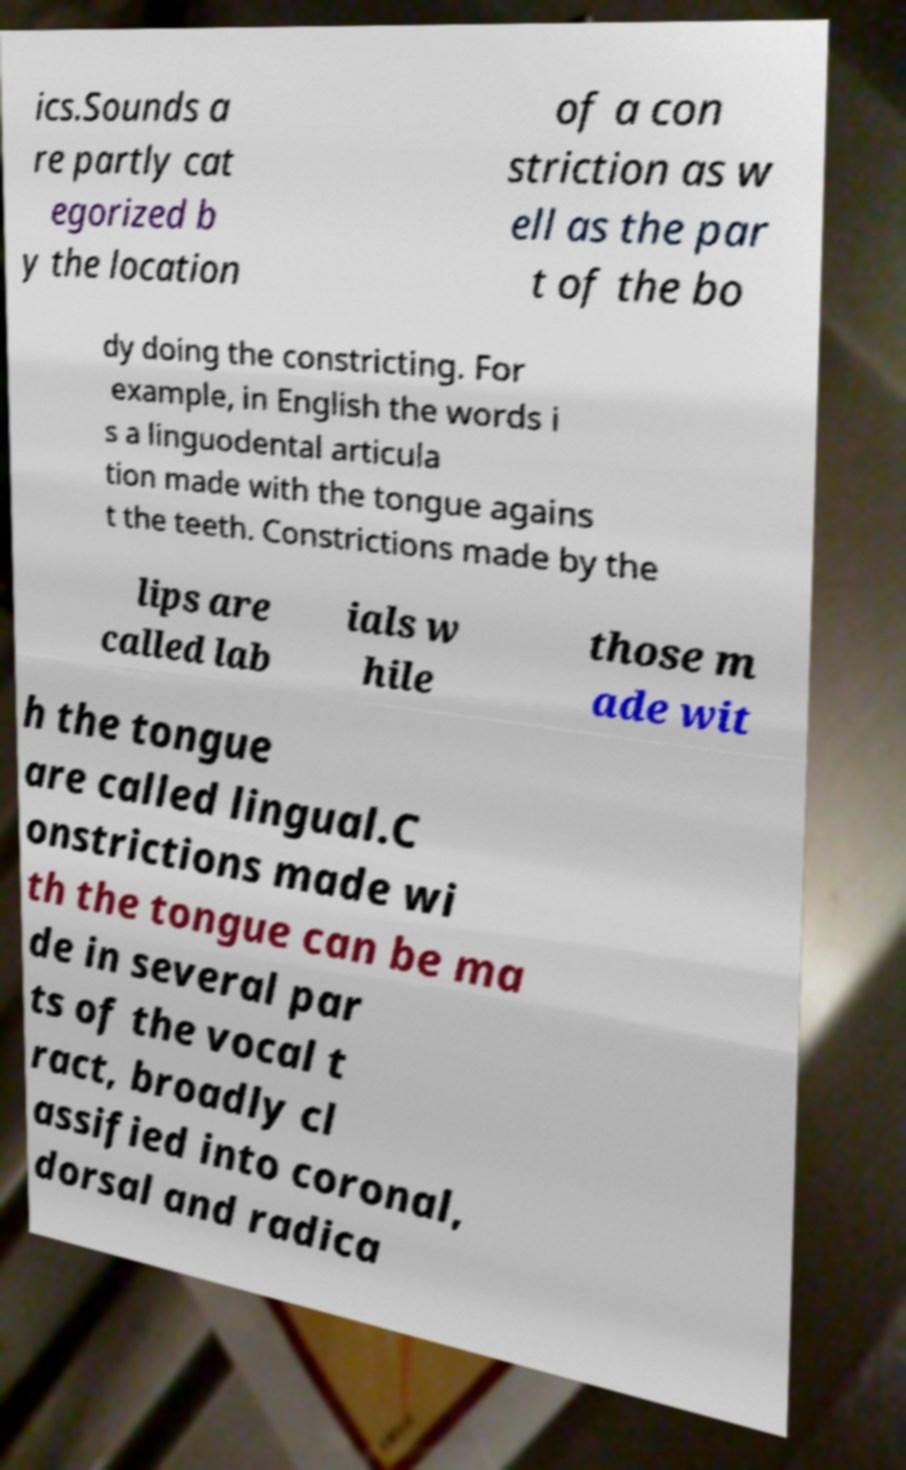Can you read and provide the text displayed in the image?This photo seems to have some interesting text. Can you extract and type it out for me? ics.Sounds a re partly cat egorized b y the location of a con striction as w ell as the par t of the bo dy doing the constricting. For example, in English the words i s a linguodental articula tion made with the tongue agains t the teeth. Constrictions made by the lips are called lab ials w hile those m ade wit h the tongue are called lingual.C onstrictions made wi th the tongue can be ma de in several par ts of the vocal t ract, broadly cl assified into coronal, dorsal and radica 